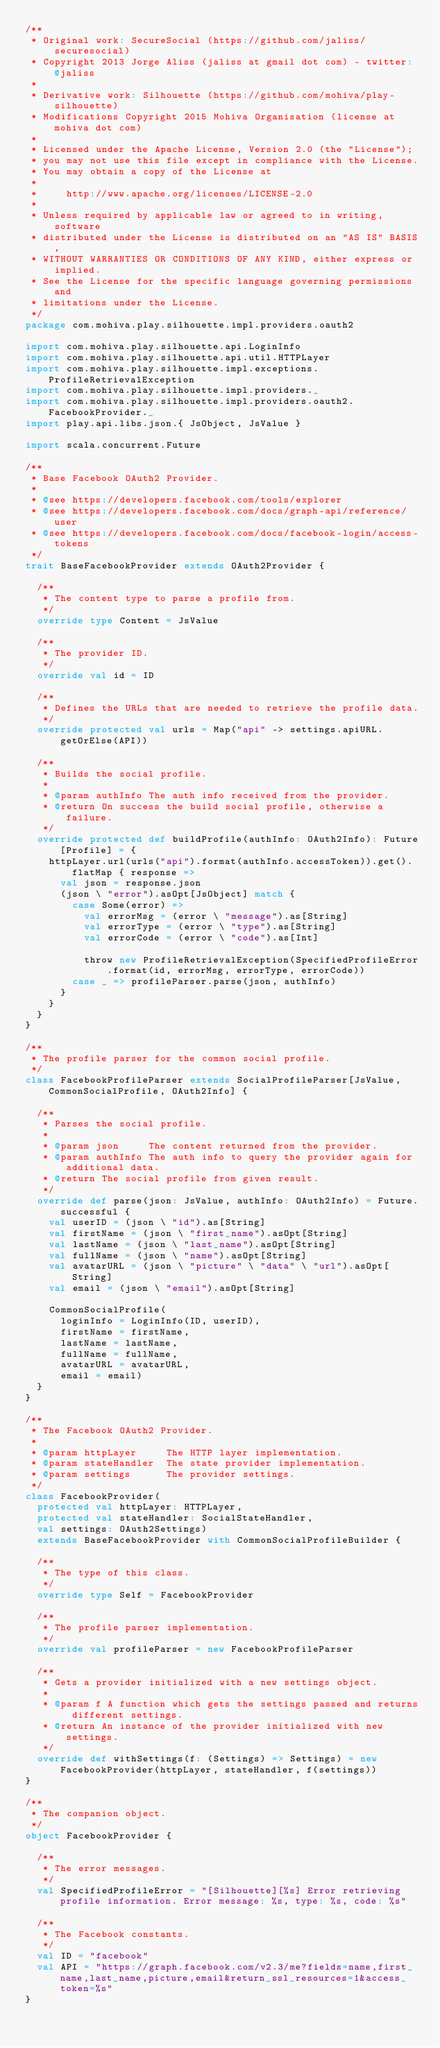<code> <loc_0><loc_0><loc_500><loc_500><_Scala_>/**
 * Original work: SecureSocial (https://github.com/jaliss/securesocial)
 * Copyright 2013 Jorge Aliss (jaliss at gmail dot com) - twitter: @jaliss
 *
 * Derivative work: Silhouette (https://github.com/mohiva/play-silhouette)
 * Modifications Copyright 2015 Mohiva Organisation (license at mohiva dot com)
 *
 * Licensed under the Apache License, Version 2.0 (the "License");
 * you may not use this file except in compliance with the License.
 * You may obtain a copy of the License at
 *
 *     http://www.apache.org/licenses/LICENSE-2.0
 *
 * Unless required by applicable law or agreed to in writing, software
 * distributed under the License is distributed on an "AS IS" BASIS,
 * WITHOUT WARRANTIES OR CONDITIONS OF ANY KIND, either express or implied.
 * See the License for the specific language governing permissions and
 * limitations under the License.
 */
package com.mohiva.play.silhouette.impl.providers.oauth2

import com.mohiva.play.silhouette.api.LoginInfo
import com.mohiva.play.silhouette.api.util.HTTPLayer
import com.mohiva.play.silhouette.impl.exceptions.ProfileRetrievalException
import com.mohiva.play.silhouette.impl.providers._
import com.mohiva.play.silhouette.impl.providers.oauth2.FacebookProvider._
import play.api.libs.json.{ JsObject, JsValue }

import scala.concurrent.Future

/**
 * Base Facebook OAuth2 Provider.
 *
 * @see https://developers.facebook.com/tools/explorer
 * @see https://developers.facebook.com/docs/graph-api/reference/user
 * @see https://developers.facebook.com/docs/facebook-login/access-tokens
 */
trait BaseFacebookProvider extends OAuth2Provider {

  /**
   * The content type to parse a profile from.
   */
  override type Content = JsValue

  /**
   * The provider ID.
   */
  override val id = ID

  /**
   * Defines the URLs that are needed to retrieve the profile data.
   */
  override protected val urls = Map("api" -> settings.apiURL.getOrElse(API))

  /**
   * Builds the social profile.
   *
   * @param authInfo The auth info received from the provider.
   * @return On success the build social profile, otherwise a failure.
   */
  override protected def buildProfile(authInfo: OAuth2Info): Future[Profile] = {
    httpLayer.url(urls("api").format(authInfo.accessToken)).get().flatMap { response =>
      val json = response.json
      (json \ "error").asOpt[JsObject] match {
        case Some(error) =>
          val errorMsg = (error \ "message").as[String]
          val errorType = (error \ "type").as[String]
          val errorCode = (error \ "code").as[Int]

          throw new ProfileRetrievalException(SpecifiedProfileError.format(id, errorMsg, errorType, errorCode))
        case _ => profileParser.parse(json, authInfo)
      }
    }
  }
}

/**
 * The profile parser for the common social profile.
 */
class FacebookProfileParser extends SocialProfileParser[JsValue, CommonSocialProfile, OAuth2Info] {

  /**
   * Parses the social profile.
   *
   * @param json     The content returned from the provider.
   * @param authInfo The auth info to query the provider again for additional data.
   * @return The social profile from given result.
   */
  override def parse(json: JsValue, authInfo: OAuth2Info) = Future.successful {
    val userID = (json \ "id").as[String]
    val firstName = (json \ "first_name").asOpt[String]
    val lastName = (json \ "last_name").asOpt[String]
    val fullName = (json \ "name").asOpt[String]
    val avatarURL = (json \ "picture" \ "data" \ "url").asOpt[String]
    val email = (json \ "email").asOpt[String]

    CommonSocialProfile(
      loginInfo = LoginInfo(ID, userID),
      firstName = firstName,
      lastName = lastName,
      fullName = fullName,
      avatarURL = avatarURL,
      email = email)
  }
}

/**
 * The Facebook OAuth2 Provider.
 *
 * @param httpLayer     The HTTP layer implementation.
 * @param stateHandler  The state provider implementation.
 * @param settings      The provider settings.
 */
class FacebookProvider(
  protected val httpLayer: HTTPLayer,
  protected val stateHandler: SocialStateHandler,
  val settings: OAuth2Settings)
  extends BaseFacebookProvider with CommonSocialProfileBuilder {

  /**
   * The type of this class.
   */
  override type Self = FacebookProvider

  /**
   * The profile parser implementation.
   */
  override val profileParser = new FacebookProfileParser

  /**
   * Gets a provider initialized with a new settings object.
   *
   * @param f A function which gets the settings passed and returns different settings.
   * @return An instance of the provider initialized with new settings.
   */
  override def withSettings(f: (Settings) => Settings) = new FacebookProvider(httpLayer, stateHandler, f(settings))
}

/**
 * The companion object.
 */
object FacebookProvider {

  /**
   * The error messages.
   */
  val SpecifiedProfileError = "[Silhouette][%s] Error retrieving profile information. Error message: %s, type: %s, code: %s"

  /**
   * The Facebook constants.
   */
  val ID = "facebook"
  val API = "https://graph.facebook.com/v2.3/me?fields=name,first_name,last_name,picture,email&return_ssl_resources=1&access_token=%s"
}
</code> 